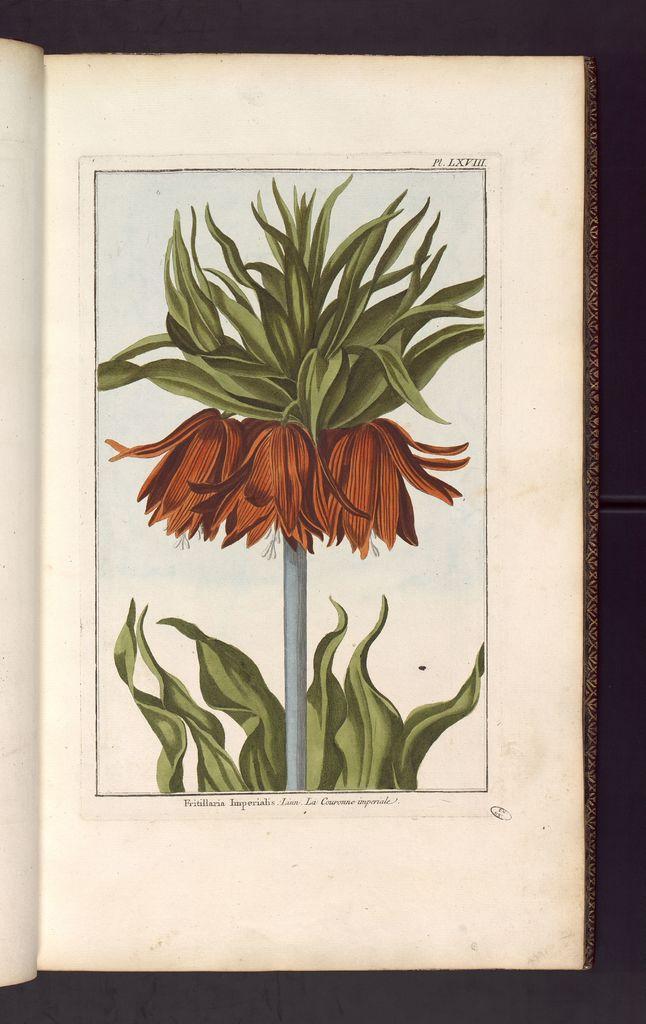Please provide a concise description of this image. In this image in the center there is one book and on the book there is drawing of flower and plant, and text and there is black background. 